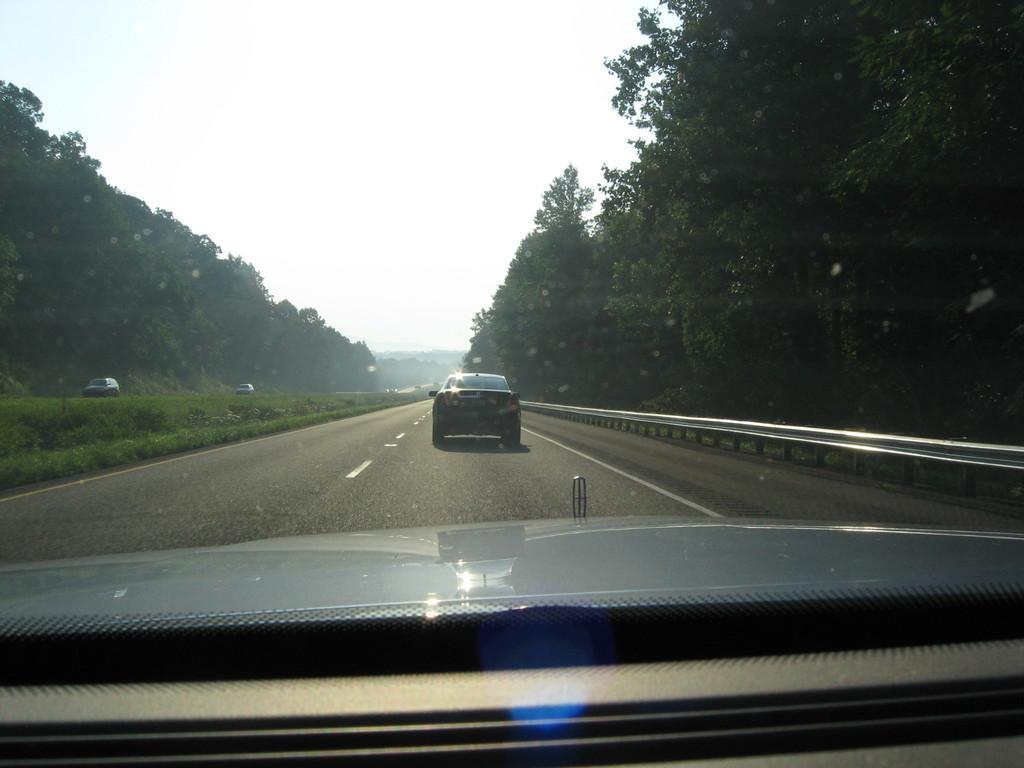Could you give a brief overview of what you see in this image? This picture is taken from a vehicle. On road there are few cars. Right side there is a fence, behind there are few trees. Left side there is some grass. Behind there are two cars and few trees. Top of image there is sky. 